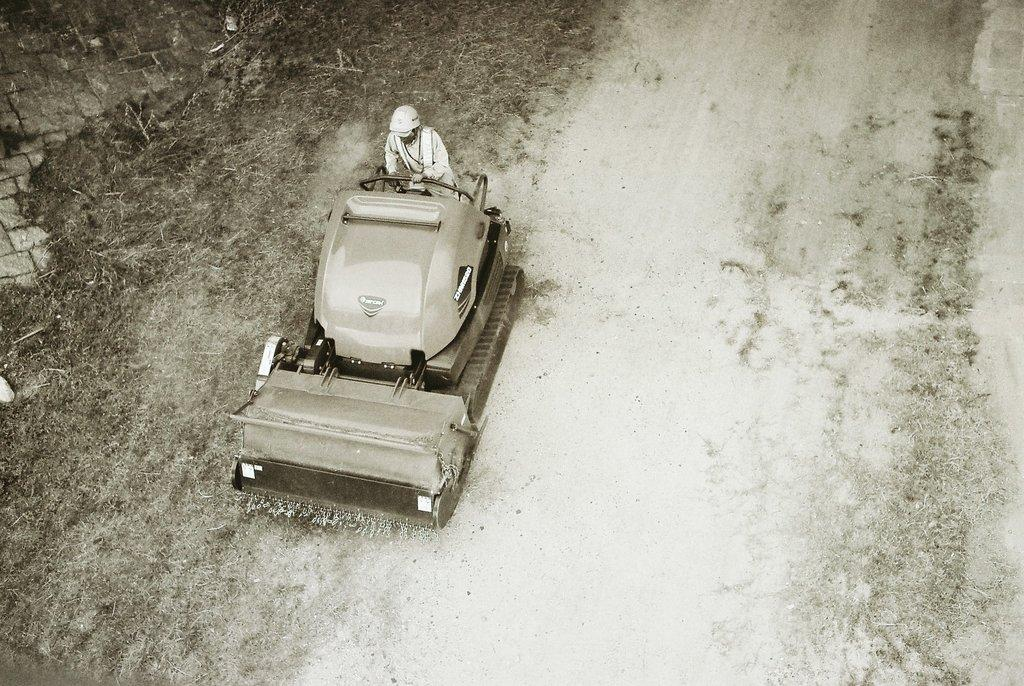What type of surface is visible in the image? There is ground visible in the image. What kind of vegetation is present on the ground? There is grass on the ground. What large object can be seen on the ground? There is a huge vehicle on the ground. Is there anyone on the vehicle? Yes, a person is on the vehicle. Where is the wrench being used in the image? There is no wrench present in the image. What type of room is visible in the image? There is no room visible in the image; it is an outdoor scene with ground, grass, a huge vehicle, and a person on the vehicle. 